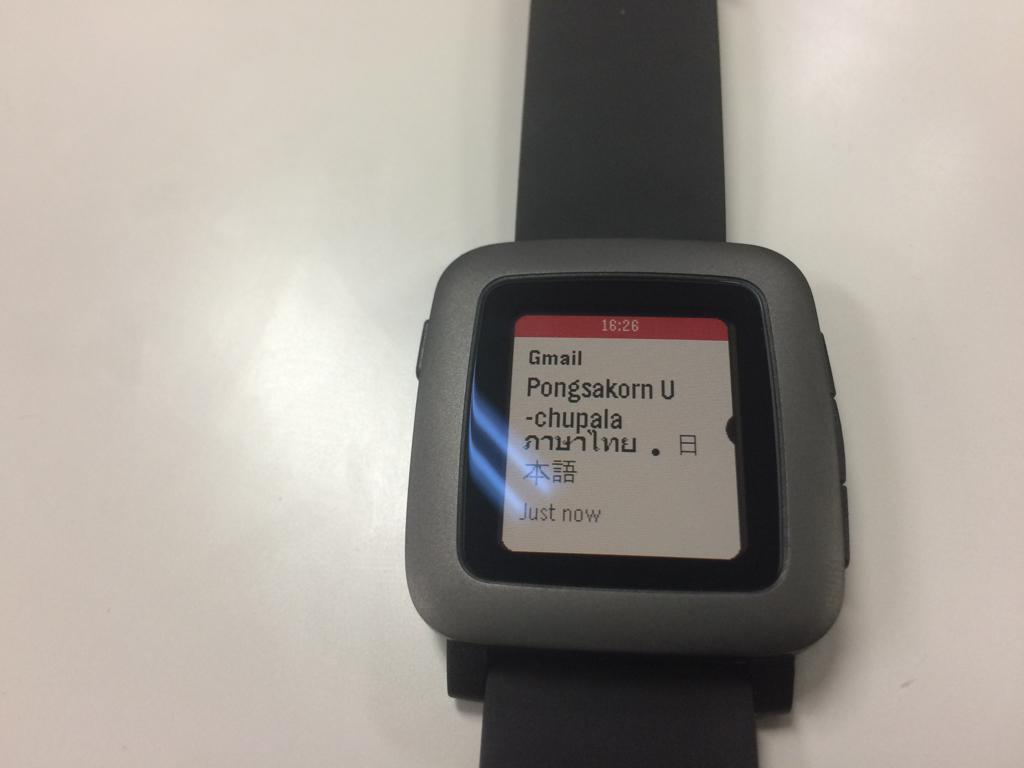Provide a one-sentence caption for the provided image. A watch open to a Gmail message that arrived just now. 